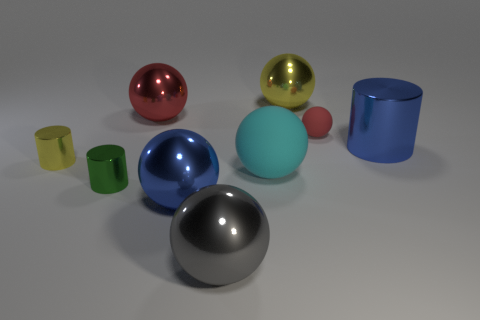There is a blue metal thing that is left of the blue cylinder; is it the same size as the tiny green object?
Offer a terse response. No. There is a large gray metallic ball; how many large red shiny things are behind it?
Your answer should be compact. 1. Are there any brown matte objects of the same size as the green shiny cylinder?
Your answer should be compact. No. Do the small matte thing and the big rubber object have the same color?
Ensure brevity in your answer.  No. What is the color of the small shiny thing that is in front of the yellow metal thing left of the big gray metal object?
Your answer should be compact. Green. How many things are in front of the yellow metal ball and on the right side of the small green cylinder?
Offer a terse response. 6. What number of big yellow things have the same shape as the tiny red matte thing?
Your answer should be compact. 1. Does the tiny red thing have the same material as the cyan sphere?
Provide a short and direct response. Yes. There is a big blue object that is behind the metal thing on the left side of the green cylinder; what shape is it?
Make the answer very short. Cylinder. There is a yellow metallic object behind the blue cylinder; how many yellow objects are on the left side of it?
Your answer should be very brief. 1. 